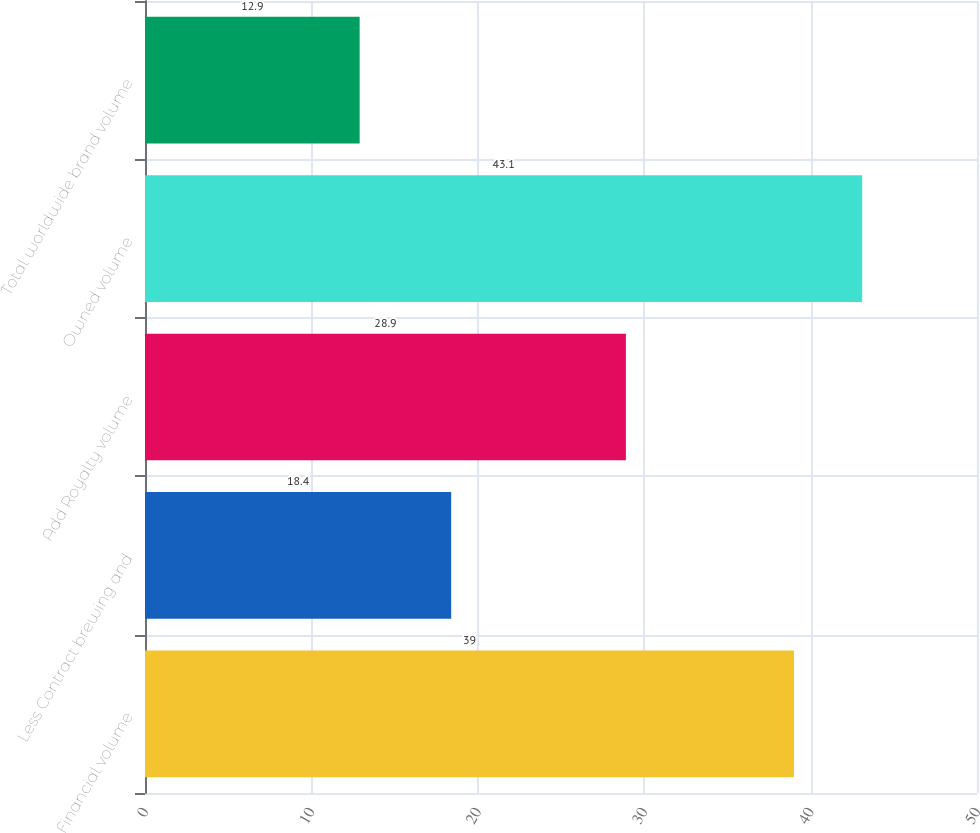Convert chart. <chart><loc_0><loc_0><loc_500><loc_500><bar_chart><fcel>Financial volume<fcel>Less Contract brewing and<fcel>Add Royalty volume<fcel>Owned volume<fcel>Total worldwide brand volume<nl><fcel>39<fcel>18.4<fcel>28.9<fcel>43.1<fcel>12.9<nl></chart> 